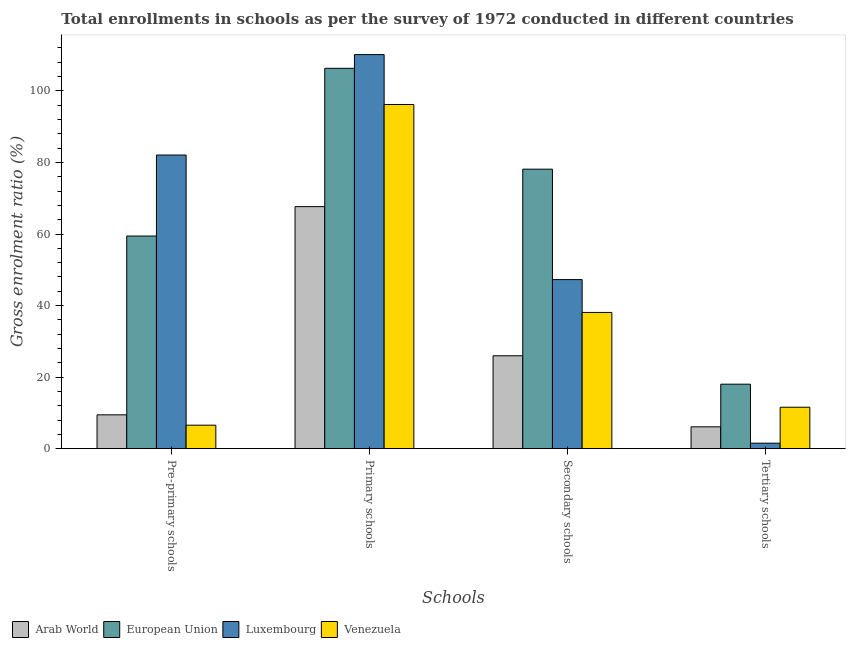How many different coloured bars are there?
Provide a short and direct response. 4. Are the number of bars per tick equal to the number of legend labels?
Offer a terse response. Yes. Are the number of bars on each tick of the X-axis equal?
Your answer should be compact. Yes. How many bars are there on the 2nd tick from the right?
Your answer should be compact. 4. What is the label of the 4th group of bars from the left?
Provide a short and direct response. Tertiary schools. What is the gross enrolment ratio in pre-primary schools in European Union?
Offer a terse response. 59.43. Across all countries, what is the maximum gross enrolment ratio in pre-primary schools?
Keep it short and to the point. 82.08. Across all countries, what is the minimum gross enrolment ratio in primary schools?
Offer a very short reply. 67.65. In which country was the gross enrolment ratio in pre-primary schools minimum?
Keep it short and to the point. Venezuela. What is the total gross enrolment ratio in primary schools in the graph?
Give a very brief answer. 380.33. What is the difference between the gross enrolment ratio in pre-primary schools in European Union and that in Arab World?
Ensure brevity in your answer.  49.97. What is the difference between the gross enrolment ratio in primary schools in Arab World and the gross enrolment ratio in secondary schools in Venezuela?
Ensure brevity in your answer.  29.57. What is the average gross enrolment ratio in tertiary schools per country?
Provide a short and direct response. 9.31. What is the difference between the gross enrolment ratio in tertiary schools and gross enrolment ratio in primary schools in Venezuela?
Provide a succinct answer. -84.62. What is the ratio of the gross enrolment ratio in pre-primary schools in Venezuela to that in Luxembourg?
Keep it short and to the point. 0.08. Is the difference between the gross enrolment ratio in tertiary schools in European Union and Venezuela greater than the difference between the gross enrolment ratio in secondary schools in European Union and Venezuela?
Your answer should be very brief. No. What is the difference between the highest and the second highest gross enrolment ratio in tertiary schools?
Your answer should be very brief. 6.44. What is the difference between the highest and the lowest gross enrolment ratio in primary schools?
Keep it short and to the point. 42.5. In how many countries, is the gross enrolment ratio in tertiary schools greater than the average gross enrolment ratio in tertiary schools taken over all countries?
Your response must be concise. 2. Is the sum of the gross enrolment ratio in tertiary schools in Luxembourg and Venezuela greater than the maximum gross enrolment ratio in secondary schools across all countries?
Provide a short and direct response. No. What does the 3rd bar from the left in Secondary schools represents?
Your answer should be compact. Luxembourg. What does the 2nd bar from the right in Tertiary schools represents?
Make the answer very short. Luxembourg. How many bars are there?
Provide a short and direct response. 16. What is the difference between two consecutive major ticks on the Y-axis?
Make the answer very short. 20. Are the values on the major ticks of Y-axis written in scientific E-notation?
Ensure brevity in your answer.  No. What is the title of the graph?
Make the answer very short. Total enrollments in schools as per the survey of 1972 conducted in different countries. Does "China" appear as one of the legend labels in the graph?
Keep it short and to the point. No. What is the label or title of the X-axis?
Offer a terse response. Schools. What is the Gross enrolment ratio (%) of Arab World in Pre-primary schools?
Offer a terse response. 9.46. What is the Gross enrolment ratio (%) of European Union in Pre-primary schools?
Keep it short and to the point. 59.43. What is the Gross enrolment ratio (%) in Luxembourg in Pre-primary schools?
Your response must be concise. 82.08. What is the Gross enrolment ratio (%) in Venezuela in Pre-primary schools?
Provide a short and direct response. 6.57. What is the Gross enrolment ratio (%) in Arab World in Primary schools?
Provide a short and direct response. 67.65. What is the Gross enrolment ratio (%) in European Union in Primary schools?
Your answer should be compact. 106.32. What is the Gross enrolment ratio (%) in Luxembourg in Primary schools?
Offer a very short reply. 110.16. What is the Gross enrolment ratio (%) of Venezuela in Primary schools?
Offer a terse response. 96.2. What is the Gross enrolment ratio (%) in Arab World in Secondary schools?
Provide a succinct answer. 25.97. What is the Gross enrolment ratio (%) of European Union in Secondary schools?
Offer a terse response. 78.13. What is the Gross enrolment ratio (%) of Luxembourg in Secondary schools?
Offer a terse response. 47.26. What is the Gross enrolment ratio (%) of Venezuela in Secondary schools?
Provide a short and direct response. 38.08. What is the Gross enrolment ratio (%) of Arab World in Tertiary schools?
Keep it short and to the point. 6.11. What is the Gross enrolment ratio (%) in European Union in Tertiary schools?
Offer a terse response. 18.03. What is the Gross enrolment ratio (%) of Luxembourg in Tertiary schools?
Keep it short and to the point. 1.54. What is the Gross enrolment ratio (%) in Venezuela in Tertiary schools?
Ensure brevity in your answer.  11.59. Across all Schools, what is the maximum Gross enrolment ratio (%) in Arab World?
Provide a succinct answer. 67.65. Across all Schools, what is the maximum Gross enrolment ratio (%) of European Union?
Your answer should be very brief. 106.32. Across all Schools, what is the maximum Gross enrolment ratio (%) of Luxembourg?
Your answer should be compact. 110.16. Across all Schools, what is the maximum Gross enrolment ratio (%) in Venezuela?
Offer a very short reply. 96.2. Across all Schools, what is the minimum Gross enrolment ratio (%) of Arab World?
Make the answer very short. 6.11. Across all Schools, what is the minimum Gross enrolment ratio (%) in European Union?
Ensure brevity in your answer.  18.03. Across all Schools, what is the minimum Gross enrolment ratio (%) of Luxembourg?
Your response must be concise. 1.54. Across all Schools, what is the minimum Gross enrolment ratio (%) of Venezuela?
Make the answer very short. 6.57. What is the total Gross enrolment ratio (%) in Arab World in the graph?
Provide a short and direct response. 109.19. What is the total Gross enrolment ratio (%) of European Union in the graph?
Provide a succinct answer. 261.91. What is the total Gross enrolment ratio (%) in Luxembourg in the graph?
Ensure brevity in your answer.  241.03. What is the total Gross enrolment ratio (%) of Venezuela in the graph?
Give a very brief answer. 152.44. What is the difference between the Gross enrolment ratio (%) in Arab World in Pre-primary schools and that in Primary schools?
Offer a very short reply. -58.19. What is the difference between the Gross enrolment ratio (%) of European Union in Pre-primary schools and that in Primary schools?
Your response must be concise. -46.89. What is the difference between the Gross enrolment ratio (%) in Luxembourg in Pre-primary schools and that in Primary schools?
Provide a succinct answer. -28.07. What is the difference between the Gross enrolment ratio (%) of Venezuela in Pre-primary schools and that in Primary schools?
Your response must be concise. -89.63. What is the difference between the Gross enrolment ratio (%) of Arab World in Pre-primary schools and that in Secondary schools?
Offer a terse response. -16.51. What is the difference between the Gross enrolment ratio (%) of European Union in Pre-primary schools and that in Secondary schools?
Your answer should be very brief. -18.7. What is the difference between the Gross enrolment ratio (%) in Luxembourg in Pre-primary schools and that in Secondary schools?
Give a very brief answer. 34.82. What is the difference between the Gross enrolment ratio (%) of Venezuela in Pre-primary schools and that in Secondary schools?
Offer a terse response. -31.51. What is the difference between the Gross enrolment ratio (%) of Arab World in Pre-primary schools and that in Tertiary schools?
Provide a short and direct response. 3.35. What is the difference between the Gross enrolment ratio (%) of European Union in Pre-primary schools and that in Tertiary schools?
Your response must be concise. 41.41. What is the difference between the Gross enrolment ratio (%) of Luxembourg in Pre-primary schools and that in Tertiary schools?
Your answer should be compact. 80.54. What is the difference between the Gross enrolment ratio (%) of Venezuela in Pre-primary schools and that in Tertiary schools?
Ensure brevity in your answer.  -5.02. What is the difference between the Gross enrolment ratio (%) of Arab World in Primary schools and that in Secondary schools?
Provide a succinct answer. 41.69. What is the difference between the Gross enrolment ratio (%) of European Union in Primary schools and that in Secondary schools?
Offer a terse response. 28.19. What is the difference between the Gross enrolment ratio (%) in Luxembourg in Primary schools and that in Secondary schools?
Offer a terse response. 62.9. What is the difference between the Gross enrolment ratio (%) of Venezuela in Primary schools and that in Secondary schools?
Make the answer very short. 58.12. What is the difference between the Gross enrolment ratio (%) in Arab World in Primary schools and that in Tertiary schools?
Provide a succinct answer. 61.55. What is the difference between the Gross enrolment ratio (%) in European Union in Primary schools and that in Tertiary schools?
Your answer should be very brief. 88.29. What is the difference between the Gross enrolment ratio (%) of Luxembourg in Primary schools and that in Tertiary schools?
Provide a short and direct response. 108.62. What is the difference between the Gross enrolment ratio (%) of Venezuela in Primary schools and that in Tertiary schools?
Offer a terse response. 84.62. What is the difference between the Gross enrolment ratio (%) in Arab World in Secondary schools and that in Tertiary schools?
Keep it short and to the point. 19.86. What is the difference between the Gross enrolment ratio (%) of European Union in Secondary schools and that in Tertiary schools?
Your answer should be very brief. 60.1. What is the difference between the Gross enrolment ratio (%) of Luxembourg in Secondary schools and that in Tertiary schools?
Provide a short and direct response. 45.72. What is the difference between the Gross enrolment ratio (%) of Venezuela in Secondary schools and that in Tertiary schools?
Keep it short and to the point. 26.5. What is the difference between the Gross enrolment ratio (%) of Arab World in Pre-primary schools and the Gross enrolment ratio (%) of European Union in Primary schools?
Provide a short and direct response. -96.86. What is the difference between the Gross enrolment ratio (%) of Arab World in Pre-primary schools and the Gross enrolment ratio (%) of Luxembourg in Primary schools?
Offer a very short reply. -100.7. What is the difference between the Gross enrolment ratio (%) of Arab World in Pre-primary schools and the Gross enrolment ratio (%) of Venezuela in Primary schools?
Provide a succinct answer. -86.75. What is the difference between the Gross enrolment ratio (%) in European Union in Pre-primary schools and the Gross enrolment ratio (%) in Luxembourg in Primary schools?
Your answer should be compact. -50.72. What is the difference between the Gross enrolment ratio (%) of European Union in Pre-primary schools and the Gross enrolment ratio (%) of Venezuela in Primary schools?
Give a very brief answer. -36.77. What is the difference between the Gross enrolment ratio (%) of Luxembourg in Pre-primary schools and the Gross enrolment ratio (%) of Venezuela in Primary schools?
Give a very brief answer. -14.12. What is the difference between the Gross enrolment ratio (%) of Arab World in Pre-primary schools and the Gross enrolment ratio (%) of European Union in Secondary schools?
Provide a succinct answer. -68.67. What is the difference between the Gross enrolment ratio (%) in Arab World in Pre-primary schools and the Gross enrolment ratio (%) in Luxembourg in Secondary schools?
Make the answer very short. -37.8. What is the difference between the Gross enrolment ratio (%) of Arab World in Pre-primary schools and the Gross enrolment ratio (%) of Venezuela in Secondary schools?
Keep it short and to the point. -28.63. What is the difference between the Gross enrolment ratio (%) in European Union in Pre-primary schools and the Gross enrolment ratio (%) in Luxembourg in Secondary schools?
Give a very brief answer. 12.17. What is the difference between the Gross enrolment ratio (%) in European Union in Pre-primary schools and the Gross enrolment ratio (%) in Venezuela in Secondary schools?
Make the answer very short. 21.35. What is the difference between the Gross enrolment ratio (%) in Luxembourg in Pre-primary schools and the Gross enrolment ratio (%) in Venezuela in Secondary schools?
Ensure brevity in your answer.  44. What is the difference between the Gross enrolment ratio (%) of Arab World in Pre-primary schools and the Gross enrolment ratio (%) of European Union in Tertiary schools?
Ensure brevity in your answer.  -8.57. What is the difference between the Gross enrolment ratio (%) of Arab World in Pre-primary schools and the Gross enrolment ratio (%) of Luxembourg in Tertiary schools?
Your answer should be compact. 7.92. What is the difference between the Gross enrolment ratio (%) of Arab World in Pre-primary schools and the Gross enrolment ratio (%) of Venezuela in Tertiary schools?
Give a very brief answer. -2.13. What is the difference between the Gross enrolment ratio (%) in European Union in Pre-primary schools and the Gross enrolment ratio (%) in Luxembourg in Tertiary schools?
Ensure brevity in your answer.  57.9. What is the difference between the Gross enrolment ratio (%) in European Union in Pre-primary schools and the Gross enrolment ratio (%) in Venezuela in Tertiary schools?
Your response must be concise. 47.85. What is the difference between the Gross enrolment ratio (%) in Luxembourg in Pre-primary schools and the Gross enrolment ratio (%) in Venezuela in Tertiary schools?
Your answer should be very brief. 70.49. What is the difference between the Gross enrolment ratio (%) in Arab World in Primary schools and the Gross enrolment ratio (%) in European Union in Secondary schools?
Offer a terse response. -10.47. What is the difference between the Gross enrolment ratio (%) of Arab World in Primary schools and the Gross enrolment ratio (%) of Luxembourg in Secondary schools?
Give a very brief answer. 20.4. What is the difference between the Gross enrolment ratio (%) in Arab World in Primary schools and the Gross enrolment ratio (%) in Venezuela in Secondary schools?
Keep it short and to the point. 29.57. What is the difference between the Gross enrolment ratio (%) in European Union in Primary schools and the Gross enrolment ratio (%) in Luxembourg in Secondary schools?
Make the answer very short. 59.06. What is the difference between the Gross enrolment ratio (%) of European Union in Primary schools and the Gross enrolment ratio (%) of Venezuela in Secondary schools?
Make the answer very short. 68.24. What is the difference between the Gross enrolment ratio (%) in Luxembourg in Primary schools and the Gross enrolment ratio (%) in Venezuela in Secondary schools?
Ensure brevity in your answer.  72.07. What is the difference between the Gross enrolment ratio (%) of Arab World in Primary schools and the Gross enrolment ratio (%) of European Union in Tertiary schools?
Provide a succinct answer. 49.63. What is the difference between the Gross enrolment ratio (%) in Arab World in Primary schools and the Gross enrolment ratio (%) in Luxembourg in Tertiary schools?
Provide a succinct answer. 66.12. What is the difference between the Gross enrolment ratio (%) in Arab World in Primary schools and the Gross enrolment ratio (%) in Venezuela in Tertiary schools?
Your response must be concise. 56.07. What is the difference between the Gross enrolment ratio (%) of European Union in Primary schools and the Gross enrolment ratio (%) of Luxembourg in Tertiary schools?
Ensure brevity in your answer.  104.78. What is the difference between the Gross enrolment ratio (%) of European Union in Primary schools and the Gross enrolment ratio (%) of Venezuela in Tertiary schools?
Your answer should be compact. 94.73. What is the difference between the Gross enrolment ratio (%) of Luxembourg in Primary schools and the Gross enrolment ratio (%) of Venezuela in Tertiary schools?
Offer a very short reply. 98.57. What is the difference between the Gross enrolment ratio (%) in Arab World in Secondary schools and the Gross enrolment ratio (%) in European Union in Tertiary schools?
Your answer should be compact. 7.94. What is the difference between the Gross enrolment ratio (%) of Arab World in Secondary schools and the Gross enrolment ratio (%) of Luxembourg in Tertiary schools?
Keep it short and to the point. 24.43. What is the difference between the Gross enrolment ratio (%) of Arab World in Secondary schools and the Gross enrolment ratio (%) of Venezuela in Tertiary schools?
Provide a succinct answer. 14.38. What is the difference between the Gross enrolment ratio (%) in European Union in Secondary schools and the Gross enrolment ratio (%) in Luxembourg in Tertiary schools?
Your response must be concise. 76.59. What is the difference between the Gross enrolment ratio (%) in European Union in Secondary schools and the Gross enrolment ratio (%) in Venezuela in Tertiary schools?
Give a very brief answer. 66.54. What is the difference between the Gross enrolment ratio (%) in Luxembourg in Secondary schools and the Gross enrolment ratio (%) in Venezuela in Tertiary schools?
Provide a short and direct response. 35.67. What is the average Gross enrolment ratio (%) in Arab World per Schools?
Give a very brief answer. 27.3. What is the average Gross enrolment ratio (%) of European Union per Schools?
Make the answer very short. 65.48. What is the average Gross enrolment ratio (%) of Luxembourg per Schools?
Make the answer very short. 60.26. What is the average Gross enrolment ratio (%) in Venezuela per Schools?
Provide a short and direct response. 38.11. What is the difference between the Gross enrolment ratio (%) of Arab World and Gross enrolment ratio (%) of European Union in Pre-primary schools?
Offer a very short reply. -49.97. What is the difference between the Gross enrolment ratio (%) in Arab World and Gross enrolment ratio (%) in Luxembourg in Pre-primary schools?
Give a very brief answer. -72.62. What is the difference between the Gross enrolment ratio (%) in Arab World and Gross enrolment ratio (%) in Venezuela in Pre-primary schools?
Offer a very short reply. 2.89. What is the difference between the Gross enrolment ratio (%) in European Union and Gross enrolment ratio (%) in Luxembourg in Pre-primary schools?
Provide a succinct answer. -22.65. What is the difference between the Gross enrolment ratio (%) in European Union and Gross enrolment ratio (%) in Venezuela in Pre-primary schools?
Your answer should be compact. 52.86. What is the difference between the Gross enrolment ratio (%) in Luxembourg and Gross enrolment ratio (%) in Venezuela in Pre-primary schools?
Offer a terse response. 75.51. What is the difference between the Gross enrolment ratio (%) in Arab World and Gross enrolment ratio (%) in European Union in Primary schools?
Your response must be concise. -38.67. What is the difference between the Gross enrolment ratio (%) of Arab World and Gross enrolment ratio (%) of Luxembourg in Primary schools?
Your response must be concise. -42.5. What is the difference between the Gross enrolment ratio (%) of Arab World and Gross enrolment ratio (%) of Venezuela in Primary schools?
Give a very brief answer. -28.55. What is the difference between the Gross enrolment ratio (%) of European Union and Gross enrolment ratio (%) of Luxembourg in Primary schools?
Give a very brief answer. -3.84. What is the difference between the Gross enrolment ratio (%) in European Union and Gross enrolment ratio (%) in Venezuela in Primary schools?
Make the answer very short. 10.12. What is the difference between the Gross enrolment ratio (%) in Luxembourg and Gross enrolment ratio (%) in Venezuela in Primary schools?
Offer a very short reply. 13.95. What is the difference between the Gross enrolment ratio (%) of Arab World and Gross enrolment ratio (%) of European Union in Secondary schools?
Your answer should be very brief. -52.16. What is the difference between the Gross enrolment ratio (%) of Arab World and Gross enrolment ratio (%) of Luxembourg in Secondary schools?
Offer a very short reply. -21.29. What is the difference between the Gross enrolment ratio (%) of Arab World and Gross enrolment ratio (%) of Venezuela in Secondary schools?
Your answer should be compact. -12.12. What is the difference between the Gross enrolment ratio (%) of European Union and Gross enrolment ratio (%) of Luxembourg in Secondary schools?
Offer a very short reply. 30.87. What is the difference between the Gross enrolment ratio (%) in European Union and Gross enrolment ratio (%) in Venezuela in Secondary schools?
Offer a very short reply. 40.04. What is the difference between the Gross enrolment ratio (%) of Luxembourg and Gross enrolment ratio (%) of Venezuela in Secondary schools?
Your answer should be very brief. 9.17. What is the difference between the Gross enrolment ratio (%) of Arab World and Gross enrolment ratio (%) of European Union in Tertiary schools?
Your answer should be compact. -11.92. What is the difference between the Gross enrolment ratio (%) in Arab World and Gross enrolment ratio (%) in Luxembourg in Tertiary schools?
Make the answer very short. 4.57. What is the difference between the Gross enrolment ratio (%) of Arab World and Gross enrolment ratio (%) of Venezuela in Tertiary schools?
Offer a terse response. -5.48. What is the difference between the Gross enrolment ratio (%) in European Union and Gross enrolment ratio (%) in Luxembourg in Tertiary schools?
Your response must be concise. 16.49. What is the difference between the Gross enrolment ratio (%) of European Union and Gross enrolment ratio (%) of Venezuela in Tertiary schools?
Give a very brief answer. 6.44. What is the difference between the Gross enrolment ratio (%) of Luxembourg and Gross enrolment ratio (%) of Venezuela in Tertiary schools?
Ensure brevity in your answer.  -10.05. What is the ratio of the Gross enrolment ratio (%) in Arab World in Pre-primary schools to that in Primary schools?
Your answer should be compact. 0.14. What is the ratio of the Gross enrolment ratio (%) of European Union in Pre-primary schools to that in Primary schools?
Provide a short and direct response. 0.56. What is the ratio of the Gross enrolment ratio (%) in Luxembourg in Pre-primary schools to that in Primary schools?
Keep it short and to the point. 0.75. What is the ratio of the Gross enrolment ratio (%) in Venezuela in Pre-primary schools to that in Primary schools?
Offer a terse response. 0.07. What is the ratio of the Gross enrolment ratio (%) of Arab World in Pre-primary schools to that in Secondary schools?
Offer a very short reply. 0.36. What is the ratio of the Gross enrolment ratio (%) in European Union in Pre-primary schools to that in Secondary schools?
Give a very brief answer. 0.76. What is the ratio of the Gross enrolment ratio (%) in Luxembourg in Pre-primary schools to that in Secondary schools?
Offer a terse response. 1.74. What is the ratio of the Gross enrolment ratio (%) in Venezuela in Pre-primary schools to that in Secondary schools?
Give a very brief answer. 0.17. What is the ratio of the Gross enrolment ratio (%) in Arab World in Pre-primary schools to that in Tertiary schools?
Keep it short and to the point. 1.55. What is the ratio of the Gross enrolment ratio (%) of European Union in Pre-primary schools to that in Tertiary schools?
Ensure brevity in your answer.  3.3. What is the ratio of the Gross enrolment ratio (%) of Luxembourg in Pre-primary schools to that in Tertiary schools?
Your answer should be compact. 53.45. What is the ratio of the Gross enrolment ratio (%) in Venezuela in Pre-primary schools to that in Tertiary schools?
Keep it short and to the point. 0.57. What is the ratio of the Gross enrolment ratio (%) of Arab World in Primary schools to that in Secondary schools?
Ensure brevity in your answer.  2.61. What is the ratio of the Gross enrolment ratio (%) of European Union in Primary schools to that in Secondary schools?
Provide a short and direct response. 1.36. What is the ratio of the Gross enrolment ratio (%) in Luxembourg in Primary schools to that in Secondary schools?
Your answer should be compact. 2.33. What is the ratio of the Gross enrolment ratio (%) of Venezuela in Primary schools to that in Secondary schools?
Your answer should be compact. 2.53. What is the ratio of the Gross enrolment ratio (%) of Arab World in Primary schools to that in Tertiary schools?
Provide a succinct answer. 11.07. What is the ratio of the Gross enrolment ratio (%) of European Union in Primary schools to that in Tertiary schools?
Your answer should be very brief. 5.9. What is the ratio of the Gross enrolment ratio (%) of Luxembourg in Primary schools to that in Tertiary schools?
Offer a very short reply. 71.73. What is the ratio of the Gross enrolment ratio (%) of Venezuela in Primary schools to that in Tertiary schools?
Make the answer very short. 8.3. What is the ratio of the Gross enrolment ratio (%) in Arab World in Secondary schools to that in Tertiary schools?
Give a very brief answer. 4.25. What is the ratio of the Gross enrolment ratio (%) in European Union in Secondary schools to that in Tertiary schools?
Offer a terse response. 4.33. What is the ratio of the Gross enrolment ratio (%) in Luxembourg in Secondary schools to that in Tertiary schools?
Your answer should be compact. 30.77. What is the ratio of the Gross enrolment ratio (%) in Venezuela in Secondary schools to that in Tertiary schools?
Keep it short and to the point. 3.29. What is the difference between the highest and the second highest Gross enrolment ratio (%) of Arab World?
Provide a short and direct response. 41.69. What is the difference between the highest and the second highest Gross enrolment ratio (%) of European Union?
Give a very brief answer. 28.19. What is the difference between the highest and the second highest Gross enrolment ratio (%) in Luxembourg?
Make the answer very short. 28.07. What is the difference between the highest and the second highest Gross enrolment ratio (%) in Venezuela?
Keep it short and to the point. 58.12. What is the difference between the highest and the lowest Gross enrolment ratio (%) in Arab World?
Offer a very short reply. 61.55. What is the difference between the highest and the lowest Gross enrolment ratio (%) in European Union?
Your answer should be compact. 88.29. What is the difference between the highest and the lowest Gross enrolment ratio (%) of Luxembourg?
Provide a short and direct response. 108.62. What is the difference between the highest and the lowest Gross enrolment ratio (%) in Venezuela?
Provide a short and direct response. 89.63. 